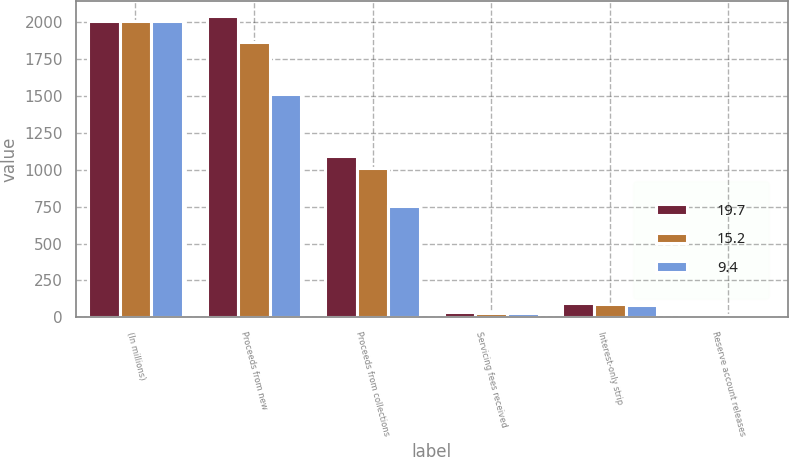<chart> <loc_0><loc_0><loc_500><loc_500><stacked_bar_chart><ecel><fcel>(In millions)<fcel>Proceeds from new<fcel>Proceeds from collections<fcel>Servicing fees received<fcel>Interest-only strip<fcel>Reserve account releases<nl><fcel>19.7<fcel>2008<fcel>2040.2<fcel>1095<fcel>37<fcel>98.6<fcel>9.4<nl><fcel>15.2<fcel>2007<fcel>1867.5<fcel>1011.8<fcel>32<fcel>88.4<fcel>15.2<nl><fcel>9.4<fcel>2006<fcel>1513.5<fcel>757.5<fcel>27.3<fcel>82.1<fcel>19.7<nl></chart> 